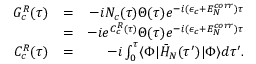Convert formula to latex. <formula><loc_0><loc_0><loc_500><loc_500>\begin{array} { r l r } { G _ { c } ^ { R } ( \tau ) } & { = } & { - i N _ { c } ( \tau ) \Theta ( \tau ) e ^ { - i ( \epsilon _ { c } + E _ { N } ^ { c o r r } ) \tau } } \\ & { = } & { - i e ^ { C _ { c } ^ { R } ( \tau ) } \Theta ( \tau ) e ^ { - i ( \epsilon _ { c } + E _ { N } ^ { c o r r } ) \tau } } \\ { C _ { c } ^ { R } ( \tau ) } & { = } & { - i \int _ { 0 } ^ { \tau } \langle \Phi | \bar { H } _ { N } ( \tau ^ { \prime } ) | \Phi \rangle d \tau ^ { \prime } . } \end{array}</formula> 